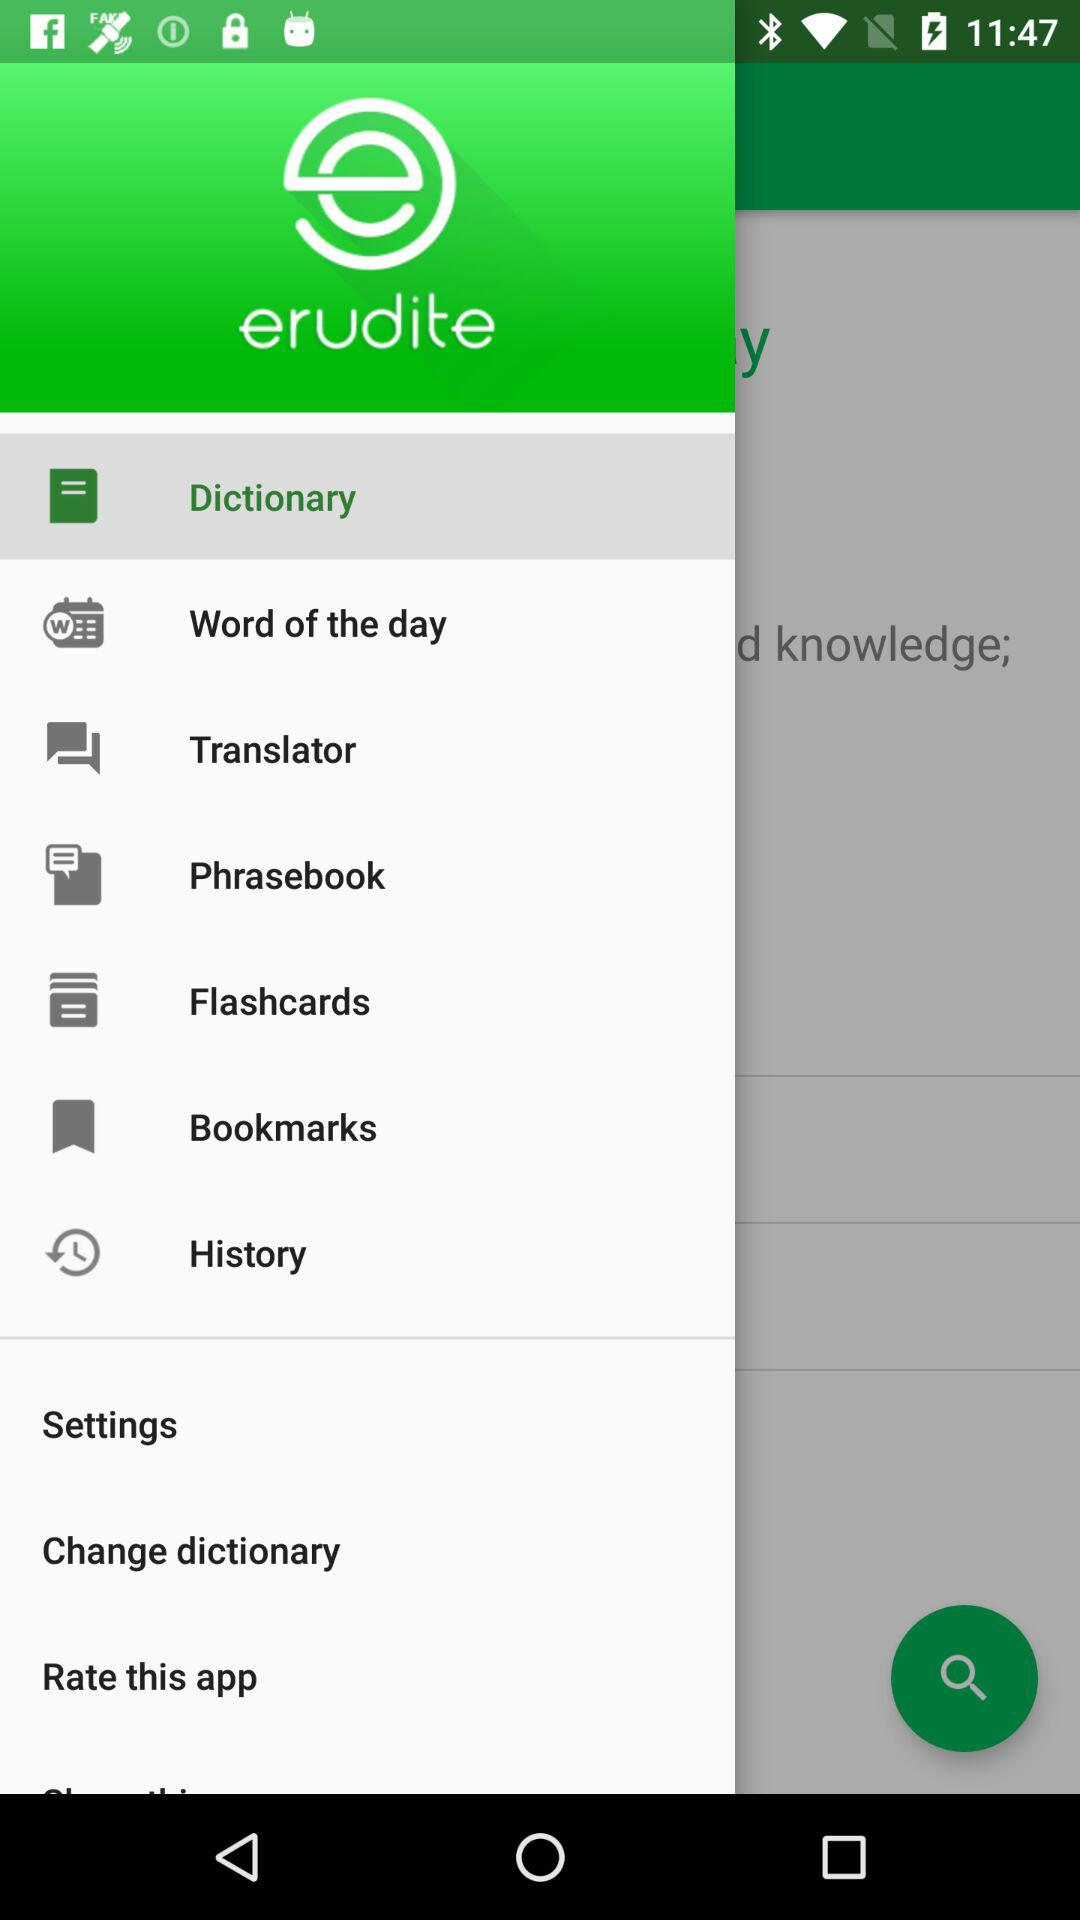What option is selected? The selected option is dictionary. 